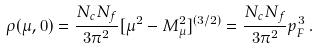<formula> <loc_0><loc_0><loc_500><loc_500>\rho ( \mu , 0 ) = \frac { N _ { c } N _ { f } } { 3 \pi ^ { 2 } } [ \mu ^ { 2 } - M _ { \mu } ^ { 2 } ] ^ { ( 3 / 2 ) } = \frac { N _ { c } N _ { f } } { 3 \pi ^ { 2 } } p _ { F } ^ { 3 } \, .</formula> 